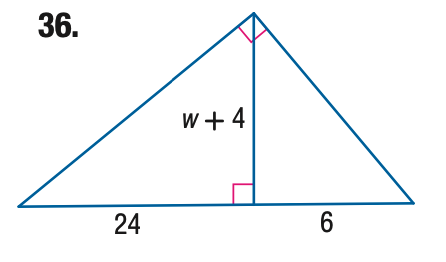Answer the mathemtical geometry problem and directly provide the correct option letter.
Question: Find the value of the variable w.
Choices: A: 4 B: 8 C: 12 D: 16 B 